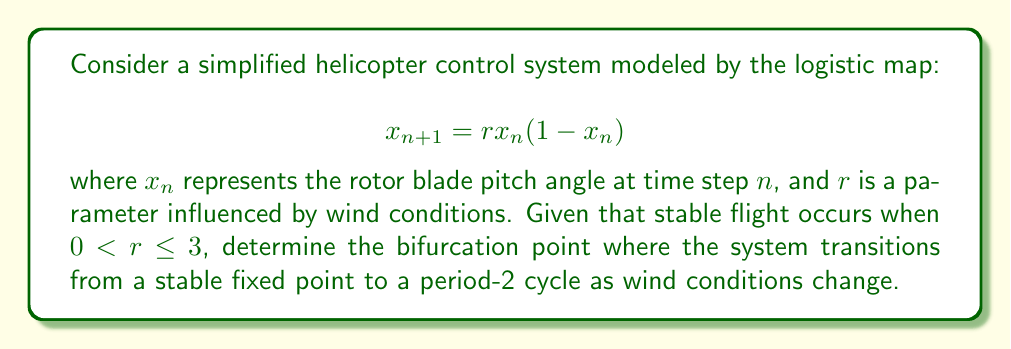Provide a solution to this math problem. To find the bifurcation point, we need to follow these steps:

1) In the logistic map, bifurcations occur when the stability of fixed points changes.

2) The fixed points of the system are given by:

   $$x = rx(1-x)$$

3) Solving this equation:

   $$x = 0$$ or $$1 = r(1-x)$$
   $$x = 0$$ or $$x = 1 - \frac{1}{r}$$

4) The non-zero fixed point $x = 1 - \frac{1}{r}$ is stable when:

   $$\left|\frac{d}{dx}(rx(1-x))\right|_{x=1-\frac{1}{r}} < 1$$

5) Evaluating this condition:

   $$\left|r(1-2x)\right|_{x=1-\frac{1}{r}} < 1$$
   $$|r(1-2(1-\frac{1}{r}))| < 1$$
   $$|r(-1+\frac{2}{r})| < 1$$
   $$|2-r| < 1$$

6) This inequality is satisfied when $1 < r < 3$.

7) The bifurcation occurs when this inequality is no longer satisfied, i.e., when $r = 3$.

Therefore, the bifurcation point where the system transitions from a stable fixed point to a period-2 cycle occurs at $r = 3$.
Answer: $r = 3$ 